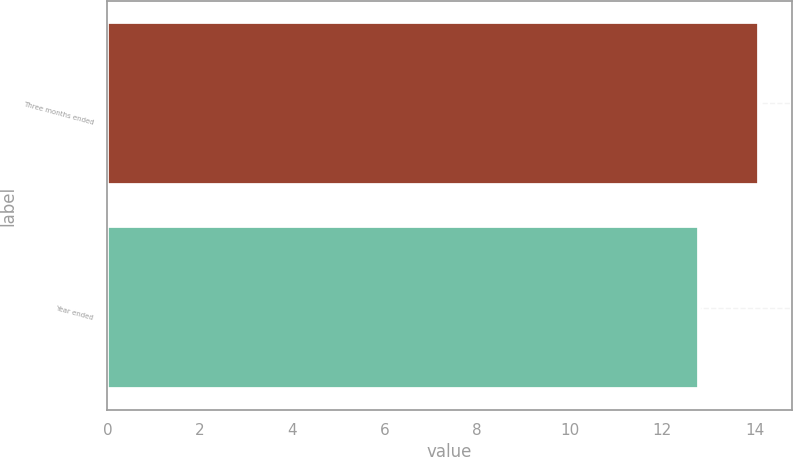Convert chart to OTSL. <chart><loc_0><loc_0><loc_500><loc_500><bar_chart><fcel>Three months ended<fcel>Year ended<nl><fcel>14.1<fcel>12.8<nl></chart> 